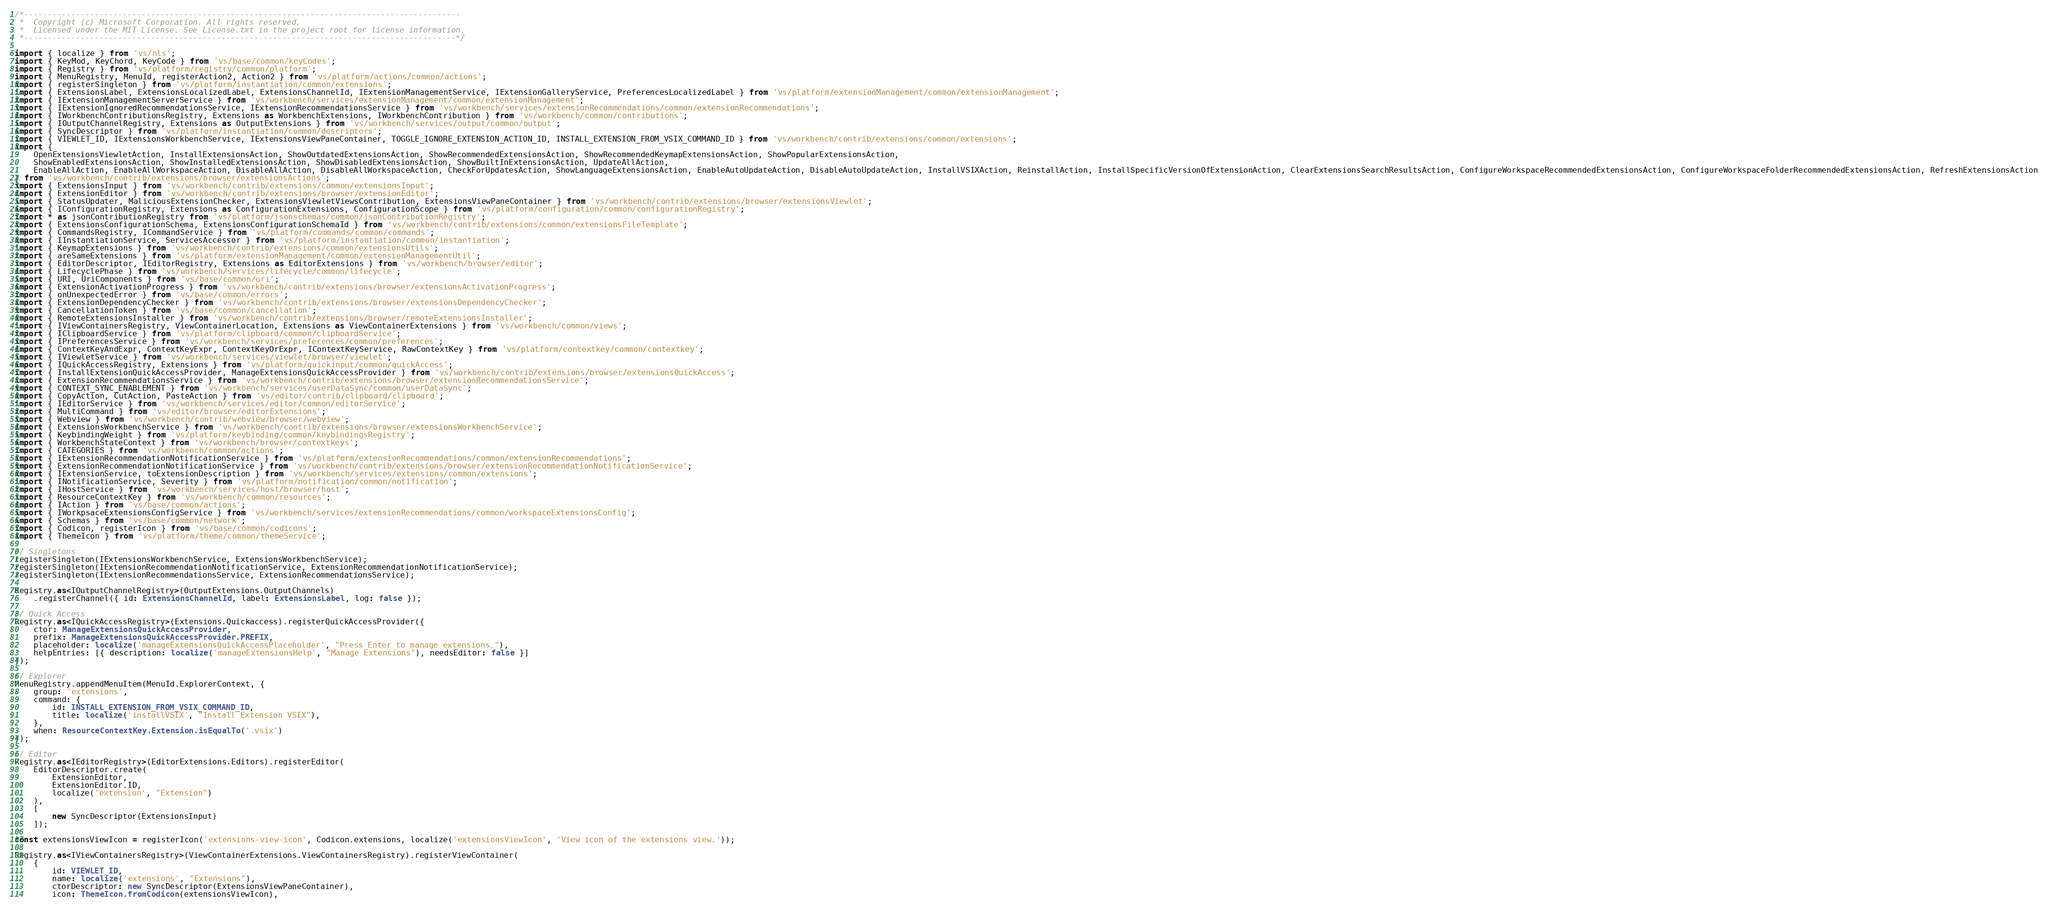Convert code to text. <code><loc_0><loc_0><loc_500><loc_500><_TypeScript_>/*---------------------------------------------------------------------------------------------
 *  Copyright (c) Microsoft Corporation. All rights reserved.
 *  Licensed under the MIT License. See License.txt in the project root for license information.
 *--------------------------------------------------------------------------------------------*/

import { localize } from 'vs/nls';
import { KeyMod, KeyChord, KeyCode } from 'vs/base/common/keyCodes';
import { Registry } from 'vs/platform/registry/common/platform';
import { MenuRegistry, MenuId, registerAction2, Action2 } from 'vs/platform/actions/common/actions';
import { registerSingleton } from 'vs/platform/instantiation/common/extensions';
import { ExtensionsLabel, ExtensionsLocalizedLabel, ExtensionsChannelId, IExtensionManagementService, IExtensionGalleryService, PreferencesLocalizedLabel } from 'vs/platform/extensionManagement/common/extensionManagement';
import { IExtensionManagementServerService } from 'vs/workbench/services/extensionManagement/common/extensionManagement';
import { IExtensionIgnoredRecommendationsService, IExtensionRecommendationsService } from 'vs/workbench/services/extensionRecommendations/common/extensionRecommendations';
import { IWorkbenchContributionsRegistry, Extensions as WorkbenchExtensions, IWorkbenchContribution } from 'vs/workbench/common/contributions';
import { IOutputChannelRegistry, Extensions as OutputExtensions } from 'vs/workbench/services/output/common/output';
import { SyncDescriptor } from 'vs/platform/instantiation/common/descriptors';
import { VIEWLET_ID, IExtensionsWorkbenchService, IExtensionsViewPaneContainer, TOGGLE_IGNORE_EXTENSION_ACTION_ID, INSTALL_EXTENSION_FROM_VSIX_COMMAND_ID } from 'vs/workbench/contrib/extensions/common/extensions';
import {
	OpenExtensionsViewletAction, InstallExtensionsAction, ShowOutdatedExtensionsAction, ShowRecommendedExtensionsAction, ShowRecommendedKeymapExtensionsAction, ShowPopularExtensionsAction,
	ShowEnabledExtensionsAction, ShowInstalledExtensionsAction, ShowDisabledExtensionsAction, ShowBuiltInExtensionsAction, UpdateAllAction,
	EnableAllAction, EnableAllWorkspaceAction, DisableAllAction, DisableAllWorkspaceAction, CheckForUpdatesAction, ShowLanguageExtensionsAction, EnableAutoUpdateAction, DisableAutoUpdateAction, InstallVSIXAction, ReinstallAction, InstallSpecificVersionOfExtensionAction, ClearExtensionsSearchResultsAction, ConfigureWorkspaceRecommendedExtensionsAction, ConfigureWorkspaceFolderRecommendedExtensionsAction, RefreshExtensionsAction
} from 'vs/workbench/contrib/extensions/browser/extensionsActions';
import { ExtensionsInput } from 'vs/workbench/contrib/extensions/common/extensionsInput';
import { ExtensionEditor } from 'vs/workbench/contrib/extensions/browser/extensionEditor';
import { StatusUpdater, MaliciousExtensionChecker, ExtensionsViewletViewsContribution, ExtensionsViewPaneContainer } from 'vs/workbench/contrib/extensions/browser/extensionsViewlet';
import { IConfigurationRegistry, Extensions as ConfigurationExtensions, ConfigurationScope } from 'vs/platform/configuration/common/configurationRegistry';
import * as jsonContributionRegistry from 'vs/platform/jsonschemas/common/jsonContributionRegistry';
import { ExtensionsConfigurationSchema, ExtensionsConfigurationSchemaId } from 'vs/workbench/contrib/extensions/common/extensionsFileTemplate';
import { CommandsRegistry, ICommandService } from 'vs/platform/commands/common/commands';
import { IInstantiationService, ServicesAccessor } from 'vs/platform/instantiation/common/instantiation';
import { KeymapExtensions } from 'vs/workbench/contrib/extensions/common/extensionsUtils';
import { areSameExtensions } from 'vs/platform/extensionManagement/common/extensionManagementUtil';
import { EditorDescriptor, IEditorRegistry, Extensions as EditorExtensions } from 'vs/workbench/browser/editor';
import { LifecyclePhase } from 'vs/workbench/services/lifecycle/common/lifecycle';
import { URI, UriComponents } from 'vs/base/common/uri';
import { ExtensionActivationProgress } from 'vs/workbench/contrib/extensions/browser/extensionsActivationProgress';
import { onUnexpectedError } from 'vs/base/common/errors';
import { ExtensionDependencyChecker } from 'vs/workbench/contrib/extensions/browser/extensionsDependencyChecker';
import { CancellationToken } from 'vs/base/common/cancellation';
import { RemoteExtensionsInstaller } from 'vs/workbench/contrib/extensions/browser/remoteExtensionsInstaller';
import { IViewContainersRegistry, ViewContainerLocation, Extensions as ViewContainerExtensions } from 'vs/workbench/common/views';
import { IClipboardService } from 'vs/platform/clipboard/common/clipboardService';
import { IPreferencesService } from 'vs/workbench/services/preferences/common/preferences';
import { ContextKeyAndExpr, ContextKeyExpr, ContextKeyOrExpr, IContextKeyService, RawContextKey } from 'vs/platform/contextkey/common/contextkey';
import { IViewletService } from 'vs/workbench/services/viewlet/browser/viewlet';
import { IQuickAccessRegistry, Extensions } from 'vs/platform/quickinput/common/quickAccess';
import { InstallExtensionQuickAccessProvider, ManageExtensionsQuickAccessProvider } from 'vs/workbench/contrib/extensions/browser/extensionsQuickAccess';
import { ExtensionRecommendationsService } from 'vs/workbench/contrib/extensions/browser/extensionRecommendationsService';
import { CONTEXT_SYNC_ENABLEMENT } from 'vs/workbench/services/userDataSync/common/userDataSync';
import { CopyAction, CutAction, PasteAction } from 'vs/editor/contrib/clipboard/clipboard';
import { IEditorService } from 'vs/workbench/services/editor/common/editorService';
import { MultiCommand } from 'vs/editor/browser/editorExtensions';
import { Webview } from 'vs/workbench/contrib/webview/browser/webview';
import { ExtensionsWorkbenchService } from 'vs/workbench/contrib/extensions/browser/extensionsWorkbenchService';
import { KeybindingWeight } from 'vs/platform/keybinding/common/keybindingsRegistry';
import { WorkbenchStateContext } from 'vs/workbench/browser/contextkeys';
import { CATEGORIES } from 'vs/workbench/common/actions';
import { IExtensionRecommendationNotificationService } from 'vs/platform/extensionRecommendations/common/extensionRecommendations';
import { ExtensionRecommendationNotificationService } from 'vs/workbench/contrib/extensions/browser/extensionRecommendationNotificationService';
import { IExtensionService, toExtensionDescription } from 'vs/workbench/services/extensions/common/extensions';
import { INotificationService, Severity } from 'vs/platform/notification/common/notification';
import { IHostService } from 'vs/workbench/services/host/browser/host';
import { ResourceContextKey } from 'vs/workbench/common/resources';
import { IAction } from 'vs/base/common/actions';
import { IWorkpsaceExtensionsConfigService } from 'vs/workbench/services/extensionRecommendations/common/workspaceExtensionsConfig';
import { Schemas } from 'vs/base/common/network';
import { Codicon, registerIcon } from 'vs/base/common/codicons';
import { ThemeIcon } from 'vs/platform/theme/common/themeService';

// Singletons
registerSingleton(IExtensionsWorkbenchService, ExtensionsWorkbenchService);
registerSingleton(IExtensionRecommendationNotificationService, ExtensionRecommendationNotificationService);
registerSingleton(IExtensionRecommendationsService, ExtensionRecommendationsService);

Registry.as<IOutputChannelRegistry>(OutputExtensions.OutputChannels)
	.registerChannel({ id: ExtensionsChannelId, label: ExtensionsLabel, log: false });

// Quick Access
Registry.as<IQuickAccessRegistry>(Extensions.Quickaccess).registerQuickAccessProvider({
	ctor: ManageExtensionsQuickAccessProvider,
	prefix: ManageExtensionsQuickAccessProvider.PREFIX,
	placeholder: localize('manageExtensionsQuickAccessPlaceholder', "Press Enter to manage extensions."),
	helpEntries: [{ description: localize('manageExtensionsHelp', "Manage Extensions"), needsEditor: false }]
});

// Explorer
MenuRegistry.appendMenuItem(MenuId.ExplorerContext, {
	group: 'extensions',
	command: {
		id: INSTALL_EXTENSION_FROM_VSIX_COMMAND_ID,
		title: localize('installVSIX', "Install Extension VSIX"),
	},
	when: ResourceContextKey.Extension.isEqualTo('.vsix')
});

// Editor
Registry.as<IEditorRegistry>(EditorExtensions.Editors).registerEditor(
	EditorDescriptor.create(
		ExtensionEditor,
		ExtensionEditor.ID,
		localize('extension', "Extension")
	),
	[
		new SyncDescriptor(ExtensionsInput)
	]);

const extensionsViewIcon = registerIcon('extensions-view-icon', Codicon.extensions, localize('extensionsViewIcon', 'View icon of the extensions view.'));

Registry.as<IViewContainersRegistry>(ViewContainerExtensions.ViewContainersRegistry).registerViewContainer(
	{
		id: VIEWLET_ID,
		name: localize('extensions', "Extensions"),
		ctorDescriptor: new SyncDescriptor(ExtensionsViewPaneContainer),
		icon: ThemeIcon.fromCodicon(extensionsViewIcon),</code> 